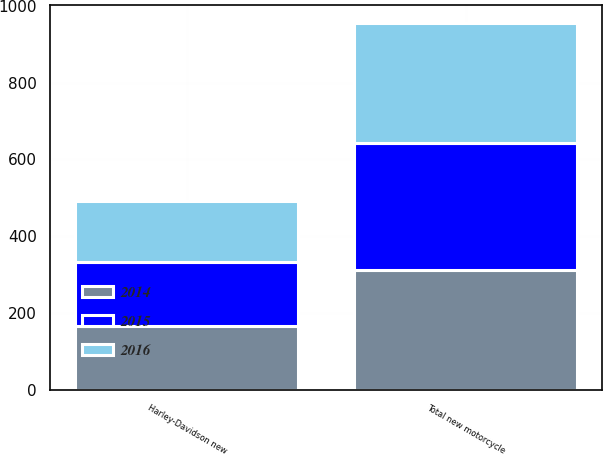Convert chart to OTSL. <chart><loc_0><loc_0><loc_500><loc_500><stacked_bar_chart><ecel><fcel>Total new motorcycle<fcel>Harley-Davidson new<nl><fcel>2016<fcel>311.7<fcel>159.5<nl><fcel>2015<fcel>328.8<fcel>165.1<nl><fcel>2014<fcel>313.6<fcel>167.1<nl></chart> 